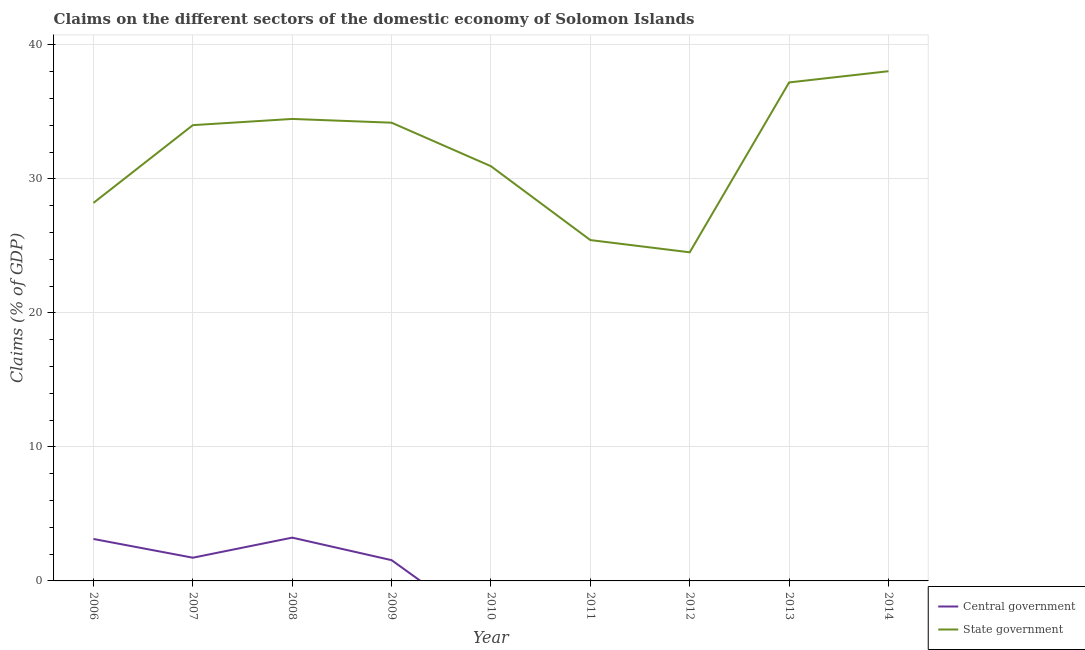How many different coloured lines are there?
Your answer should be compact. 2. Does the line corresponding to claims on state government intersect with the line corresponding to claims on central government?
Provide a short and direct response. No. Is the number of lines equal to the number of legend labels?
Ensure brevity in your answer.  No. What is the claims on state government in 2012?
Your answer should be very brief. 24.53. Across all years, what is the maximum claims on state government?
Provide a succinct answer. 38.04. Across all years, what is the minimum claims on state government?
Offer a terse response. 24.53. In which year was the claims on central government maximum?
Make the answer very short. 2008. What is the total claims on state government in the graph?
Your answer should be compact. 287.06. What is the difference between the claims on state government in 2009 and that in 2011?
Provide a short and direct response. 8.76. What is the difference between the claims on central government in 2006 and the claims on state government in 2007?
Provide a succinct answer. -30.88. What is the average claims on state government per year?
Ensure brevity in your answer.  31.9. In the year 2009, what is the difference between the claims on central government and claims on state government?
Your answer should be very brief. -32.65. In how many years, is the claims on state government greater than 28 %?
Ensure brevity in your answer.  7. What is the ratio of the claims on state government in 2010 to that in 2013?
Make the answer very short. 0.83. Is the difference between the claims on state government in 2006 and 2009 greater than the difference between the claims on central government in 2006 and 2009?
Give a very brief answer. No. What is the difference between the highest and the second highest claims on state government?
Keep it short and to the point. 0.84. What is the difference between the highest and the lowest claims on state government?
Ensure brevity in your answer.  13.51. In how many years, is the claims on central government greater than the average claims on central government taken over all years?
Ensure brevity in your answer.  4. Is the sum of the claims on state government in 2006 and 2009 greater than the maximum claims on central government across all years?
Provide a short and direct response. Yes. Is the claims on central government strictly greater than the claims on state government over the years?
Your answer should be very brief. No. How many lines are there?
Your response must be concise. 2. How many years are there in the graph?
Make the answer very short. 9. What is the difference between two consecutive major ticks on the Y-axis?
Keep it short and to the point. 10. Are the values on the major ticks of Y-axis written in scientific E-notation?
Your answer should be compact. No. How are the legend labels stacked?
Ensure brevity in your answer.  Vertical. What is the title of the graph?
Provide a short and direct response. Claims on the different sectors of the domestic economy of Solomon Islands. What is the label or title of the Y-axis?
Ensure brevity in your answer.  Claims (% of GDP). What is the Claims (% of GDP) in Central government in 2006?
Your response must be concise. 3.13. What is the Claims (% of GDP) in State government in 2006?
Offer a terse response. 28.21. What is the Claims (% of GDP) of Central government in 2007?
Your answer should be compact. 1.73. What is the Claims (% of GDP) of State government in 2007?
Make the answer very short. 34.01. What is the Claims (% of GDP) in Central government in 2008?
Offer a terse response. 3.23. What is the Claims (% of GDP) of State government in 2008?
Give a very brief answer. 34.48. What is the Claims (% of GDP) of Central government in 2009?
Make the answer very short. 1.55. What is the Claims (% of GDP) in State government in 2009?
Provide a short and direct response. 34.2. What is the Claims (% of GDP) in State government in 2010?
Your response must be concise. 30.95. What is the Claims (% of GDP) in State government in 2011?
Your answer should be compact. 25.44. What is the Claims (% of GDP) of Central government in 2012?
Offer a terse response. 0. What is the Claims (% of GDP) in State government in 2012?
Your answer should be compact. 24.53. What is the Claims (% of GDP) in State government in 2013?
Keep it short and to the point. 37.2. What is the Claims (% of GDP) in Central government in 2014?
Provide a succinct answer. 0. What is the Claims (% of GDP) of State government in 2014?
Your response must be concise. 38.04. Across all years, what is the maximum Claims (% of GDP) in Central government?
Make the answer very short. 3.23. Across all years, what is the maximum Claims (% of GDP) of State government?
Your answer should be compact. 38.04. Across all years, what is the minimum Claims (% of GDP) of State government?
Ensure brevity in your answer.  24.53. What is the total Claims (% of GDP) in Central government in the graph?
Your response must be concise. 9.64. What is the total Claims (% of GDP) of State government in the graph?
Offer a terse response. 287.06. What is the difference between the Claims (% of GDP) of Central government in 2006 and that in 2007?
Keep it short and to the point. 1.4. What is the difference between the Claims (% of GDP) in State government in 2006 and that in 2007?
Your response must be concise. -5.8. What is the difference between the Claims (% of GDP) of Central government in 2006 and that in 2008?
Give a very brief answer. -0.1. What is the difference between the Claims (% of GDP) in State government in 2006 and that in 2008?
Your response must be concise. -6.27. What is the difference between the Claims (% of GDP) of Central government in 2006 and that in 2009?
Your response must be concise. 1.58. What is the difference between the Claims (% of GDP) of State government in 2006 and that in 2009?
Provide a succinct answer. -5.99. What is the difference between the Claims (% of GDP) in State government in 2006 and that in 2010?
Make the answer very short. -2.74. What is the difference between the Claims (% of GDP) of State government in 2006 and that in 2011?
Offer a very short reply. 2.77. What is the difference between the Claims (% of GDP) in State government in 2006 and that in 2012?
Offer a terse response. 3.69. What is the difference between the Claims (% of GDP) in State government in 2006 and that in 2013?
Provide a succinct answer. -8.99. What is the difference between the Claims (% of GDP) of State government in 2006 and that in 2014?
Offer a terse response. -9.83. What is the difference between the Claims (% of GDP) of Central government in 2007 and that in 2008?
Provide a succinct answer. -1.5. What is the difference between the Claims (% of GDP) of State government in 2007 and that in 2008?
Make the answer very short. -0.46. What is the difference between the Claims (% of GDP) of Central government in 2007 and that in 2009?
Your response must be concise. 0.18. What is the difference between the Claims (% of GDP) in State government in 2007 and that in 2009?
Your answer should be compact. -0.18. What is the difference between the Claims (% of GDP) of State government in 2007 and that in 2010?
Your answer should be very brief. 3.07. What is the difference between the Claims (% of GDP) in State government in 2007 and that in 2011?
Make the answer very short. 8.58. What is the difference between the Claims (% of GDP) of State government in 2007 and that in 2012?
Give a very brief answer. 9.49. What is the difference between the Claims (% of GDP) of State government in 2007 and that in 2013?
Provide a succinct answer. -3.19. What is the difference between the Claims (% of GDP) in State government in 2007 and that in 2014?
Offer a very short reply. -4.03. What is the difference between the Claims (% of GDP) in Central government in 2008 and that in 2009?
Keep it short and to the point. 1.68. What is the difference between the Claims (% of GDP) of State government in 2008 and that in 2009?
Give a very brief answer. 0.28. What is the difference between the Claims (% of GDP) in State government in 2008 and that in 2010?
Make the answer very short. 3.53. What is the difference between the Claims (% of GDP) in State government in 2008 and that in 2011?
Provide a short and direct response. 9.04. What is the difference between the Claims (% of GDP) in State government in 2008 and that in 2012?
Provide a succinct answer. 9.95. What is the difference between the Claims (% of GDP) of State government in 2008 and that in 2013?
Your answer should be very brief. -2.72. What is the difference between the Claims (% of GDP) in State government in 2008 and that in 2014?
Keep it short and to the point. -3.56. What is the difference between the Claims (% of GDP) in State government in 2009 and that in 2010?
Keep it short and to the point. 3.25. What is the difference between the Claims (% of GDP) of State government in 2009 and that in 2011?
Provide a succinct answer. 8.76. What is the difference between the Claims (% of GDP) of State government in 2009 and that in 2012?
Your response must be concise. 9.67. What is the difference between the Claims (% of GDP) of State government in 2009 and that in 2013?
Give a very brief answer. -3. What is the difference between the Claims (% of GDP) in State government in 2009 and that in 2014?
Offer a very short reply. -3.84. What is the difference between the Claims (% of GDP) of State government in 2010 and that in 2011?
Make the answer very short. 5.51. What is the difference between the Claims (% of GDP) in State government in 2010 and that in 2012?
Your response must be concise. 6.42. What is the difference between the Claims (% of GDP) of State government in 2010 and that in 2013?
Give a very brief answer. -6.25. What is the difference between the Claims (% of GDP) in State government in 2010 and that in 2014?
Keep it short and to the point. -7.09. What is the difference between the Claims (% of GDP) in State government in 2011 and that in 2012?
Provide a short and direct response. 0.91. What is the difference between the Claims (% of GDP) of State government in 2011 and that in 2013?
Provide a succinct answer. -11.76. What is the difference between the Claims (% of GDP) of State government in 2011 and that in 2014?
Ensure brevity in your answer.  -12.6. What is the difference between the Claims (% of GDP) of State government in 2012 and that in 2013?
Keep it short and to the point. -12.68. What is the difference between the Claims (% of GDP) of State government in 2012 and that in 2014?
Provide a short and direct response. -13.51. What is the difference between the Claims (% of GDP) in State government in 2013 and that in 2014?
Give a very brief answer. -0.84. What is the difference between the Claims (% of GDP) in Central government in 2006 and the Claims (% of GDP) in State government in 2007?
Give a very brief answer. -30.88. What is the difference between the Claims (% of GDP) of Central government in 2006 and the Claims (% of GDP) of State government in 2008?
Your answer should be compact. -31.35. What is the difference between the Claims (% of GDP) in Central government in 2006 and the Claims (% of GDP) in State government in 2009?
Ensure brevity in your answer.  -31.07. What is the difference between the Claims (% of GDP) of Central government in 2006 and the Claims (% of GDP) of State government in 2010?
Make the answer very short. -27.82. What is the difference between the Claims (% of GDP) of Central government in 2006 and the Claims (% of GDP) of State government in 2011?
Your answer should be very brief. -22.31. What is the difference between the Claims (% of GDP) in Central government in 2006 and the Claims (% of GDP) in State government in 2012?
Your answer should be very brief. -21.39. What is the difference between the Claims (% of GDP) of Central government in 2006 and the Claims (% of GDP) of State government in 2013?
Offer a terse response. -34.07. What is the difference between the Claims (% of GDP) in Central government in 2006 and the Claims (% of GDP) in State government in 2014?
Give a very brief answer. -34.91. What is the difference between the Claims (% of GDP) of Central government in 2007 and the Claims (% of GDP) of State government in 2008?
Your answer should be compact. -32.75. What is the difference between the Claims (% of GDP) of Central government in 2007 and the Claims (% of GDP) of State government in 2009?
Make the answer very short. -32.47. What is the difference between the Claims (% of GDP) of Central government in 2007 and the Claims (% of GDP) of State government in 2010?
Your answer should be very brief. -29.22. What is the difference between the Claims (% of GDP) in Central government in 2007 and the Claims (% of GDP) in State government in 2011?
Offer a very short reply. -23.71. What is the difference between the Claims (% of GDP) in Central government in 2007 and the Claims (% of GDP) in State government in 2012?
Your answer should be very brief. -22.79. What is the difference between the Claims (% of GDP) of Central government in 2007 and the Claims (% of GDP) of State government in 2013?
Your response must be concise. -35.47. What is the difference between the Claims (% of GDP) of Central government in 2007 and the Claims (% of GDP) of State government in 2014?
Provide a succinct answer. -36.31. What is the difference between the Claims (% of GDP) of Central government in 2008 and the Claims (% of GDP) of State government in 2009?
Provide a short and direct response. -30.97. What is the difference between the Claims (% of GDP) of Central government in 2008 and the Claims (% of GDP) of State government in 2010?
Your answer should be compact. -27.72. What is the difference between the Claims (% of GDP) in Central government in 2008 and the Claims (% of GDP) in State government in 2011?
Provide a succinct answer. -22.21. What is the difference between the Claims (% of GDP) in Central government in 2008 and the Claims (% of GDP) in State government in 2012?
Offer a terse response. -21.29. What is the difference between the Claims (% of GDP) of Central government in 2008 and the Claims (% of GDP) of State government in 2013?
Provide a short and direct response. -33.97. What is the difference between the Claims (% of GDP) in Central government in 2008 and the Claims (% of GDP) in State government in 2014?
Provide a succinct answer. -34.81. What is the difference between the Claims (% of GDP) in Central government in 2009 and the Claims (% of GDP) in State government in 2010?
Provide a succinct answer. -29.4. What is the difference between the Claims (% of GDP) of Central government in 2009 and the Claims (% of GDP) of State government in 2011?
Provide a succinct answer. -23.89. What is the difference between the Claims (% of GDP) of Central government in 2009 and the Claims (% of GDP) of State government in 2012?
Make the answer very short. -22.98. What is the difference between the Claims (% of GDP) in Central government in 2009 and the Claims (% of GDP) in State government in 2013?
Provide a short and direct response. -35.65. What is the difference between the Claims (% of GDP) in Central government in 2009 and the Claims (% of GDP) in State government in 2014?
Offer a terse response. -36.49. What is the average Claims (% of GDP) in Central government per year?
Ensure brevity in your answer.  1.07. What is the average Claims (% of GDP) of State government per year?
Keep it short and to the point. 31.89. In the year 2006, what is the difference between the Claims (% of GDP) of Central government and Claims (% of GDP) of State government?
Ensure brevity in your answer.  -25.08. In the year 2007, what is the difference between the Claims (% of GDP) in Central government and Claims (% of GDP) in State government?
Provide a short and direct response. -32.28. In the year 2008, what is the difference between the Claims (% of GDP) of Central government and Claims (% of GDP) of State government?
Ensure brevity in your answer.  -31.25. In the year 2009, what is the difference between the Claims (% of GDP) of Central government and Claims (% of GDP) of State government?
Offer a very short reply. -32.65. What is the ratio of the Claims (% of GDP) of Central government in 2006 to that in 2007?
Offer a very short reply. 1.81. What is the ratio of the Claims (% of GDP) of State government in 2006 to that in 2007?
Offer a terse response. 0.83. What is the ratio of the Claims (% of GDP) in Central government in 2006 to that in 2008?
Give a very brief answer. 0.97. What is the ratio of the Claims (% of GDP) in State government in 2006 to that in 2008?
Your response must be concise. 0.82. What is the ratio of the Claims (% of GDP) in Central government in 2006 to that in 2009?
Your answer should be compact. 2.02. What is the ratio of the Claims (% of GDP) in State government in 2006 to that in 2009?
Provide a succinct answer. 0.82. What is the ratio of the Claims (% of GDP) of State government in 2006 to that in 2010?
Give a very brief answer. 0.91. What is the ratio of the Claims (% of GDP) in State government in 2006 to that in 2011?
Make the answer very short. 1.11. What is the ratio of the Claims (% of GDP) in State government in 2006 to that in 2012?
Keep it short and to the point. 1.15. What is the ratio of the Claims (% of GDP) in State government in 2006 to that in 2013?
Your answer should be compact. 0.76. What is the ratio of the Claims (% of GDP) of State government in 2006 to that in 2014?
Provide a succinct answer. 0.74. What is the ratio of the Claims (% of GDP) in Central government in 2007 to that in 2008?
Offer a terse response. 0.54. What is the ratio of the Claims (% of GDP) in State government in 2007 to that in 2008?
Your answer should be very brief. 0.99. What is the ratio of the Claims (% of GDP) of Central government in 2007 to that in 2009?
Keep it short and to the point. 1.12. What is the ratio of the Claims (% of GDP) in State government in 2007 to that in 2009?
Offer a very short reply. 0.99. What is the ratio of the Claims (% of GDP) in State government in 2007 to that in 2010?
Ensure brevity in your answer.  1.1. What is the ratio of the Claims (% of GDP) of State government in 2007 to that in 2011?
Your answer should be very brief. 1.34. What is the ratio of the Claims (% of GDP) in State government in 2007 to that in 2012?
Your response must be concise. 1.39. What is the ratio of the Claims (% of GDP) in State government in 2007 to that in 2013?
Offer a very short reply. 0.91. What is the ratio of the Claims (% of GDP) in State government in 2007 to that in 2014?
Provide a succinct answer. 0.89. What is the ratio of the Claims (% of GDP) in Central government in 2008 to that in 2009?
Offer a very short reply. 2.08. What is the ratio of the Claims (% of GDP) of State government in 2008 to that in 2009?
Keep it short and to the point. 1.01. What is the ratio of the Claims (% of GDP) in State government in 2008 to that in 2010?
Your response must be concise. 1.11. What is the ratio of the Claims (% of GDP) of State government in 2008 to that in 2011?
Provide a short and direct response. 1.36. What is the ratio of the Claims (% of GDP) of State government in 2008 to that in 2012?
Give a very brief answer. 1.41. What is the ratio of the Claims (% of GDP) in State government in 2008 to that in 2013?
Ensure brevity in your answer.  0.93. What is the ratio of the Claims (% of GDP) in State government in 2008 to that in 2014?
Offer a very short reply. 0.91. What is the ratio of the Claims (% of GDP) of State government in 2009 to that in 2010?
Provide a short and direct response. 1.1. What is the ratio of the Claims (% of GDP) of State government in 2009 to that in 2011?
Offer a very short reply. 1.34. What is the ratio of the Claims (% of GDP) of State government in 2009 to that in 2012?
Your answer should be compact. 1.39. What is the ratio of the Claims (% of GDP) of State government in 2009 to that in 2013?
Make the answer very short. 0.92. What is the ratio of the Claims (% of GDP) of State government in 2009 to that in 2014?
Provide a short and direct response. 0.9. What is the ratio of the Claims (% of GDP) in State government in 2010 to that in 2011?
Your answer should be very brief. 1.22. What is the ratio of the Claims (% of GDP) of State government in 2010 to that in 2012?
Ensure brevity in your answer.  1.26. What is the ratio of the Claims (% of GDP) of State government in 2010 to that in 2013?
Your answer should be compact. 0.83. What is the ratio of the Claims (% of GDP) in State government in 2010 to that in 2014?
Offer a terse response. 0.81. What is the ratio of the Claims (% of GDP) in State government in 2011 to that in 2012?
Provide a short and direct response. 1.04. What is the ratio of the Claims (% of GDP) in State government in 2011 to that in 2013?
Offer a very short reply. 0.68. What is the ratio of the Claims (% of GDP) of State government in 2011 to that in 2014?
Make the answer very short. 0.67. What is the ratio of the Claims (% of GDP) in State government in 2012 to that in 2013?
Your answer should be compact. 0.66. What is the ratio of the Claims (% of GDP) of State government in 2012 to that in 2014?
Offer a terse response. 0.64. What is the difference between the highest and the second highest Claims (% of GDP) in Central government?
Provide a short and direct response. 0.1. What is the difference between the highest and the second highest Claims (% of GDP) of State government?
Provide a succinct answer. 0.84. What is the difference between the highest and the lowest Claims (% of GDP) of Central government?
Offer a very short reply. 3.23. What is the difference between the highest and the lowest Claims (% of GDP) of State government?
Keep it short and to the point. 13.51. 